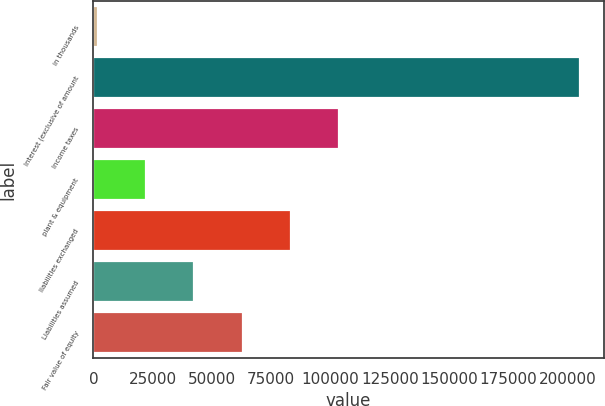Convert chart to OTSL. <chart><loc_0><loc_0><loc_500><loc_500><bar_chart><fcel>in thousands<fcel>Interest (exclusive of amount<fcel>Income taxes<fcel>plant & equipment<fcel>liabilities exchanged<fcel>Liabilities assumed<fcel>Fair value of equity<nl><fcel>2011<fcel>205088<fcel>103550<fcel>22318.7<fcel>83241.8<fcel>42626.4<fcel>62934.1<nl></chart> 